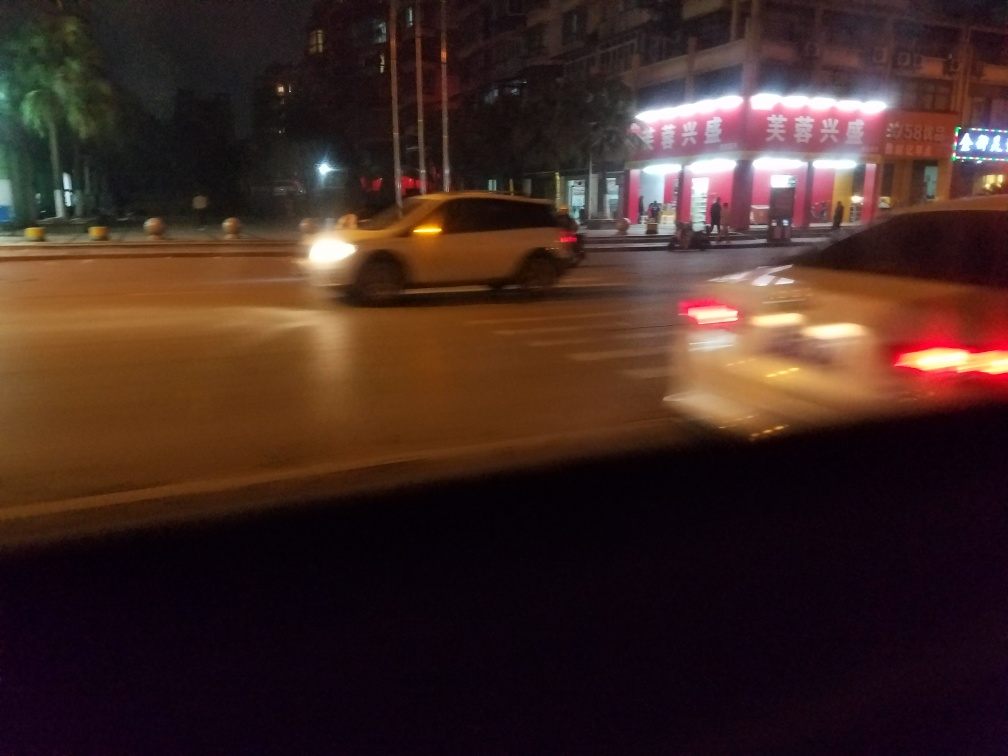What time of day does this image represent, and how can you tell? The image likely represents nighttime, as indicated by the darkness of the sky and the artificial lighting from street lamps and building signs. The lack of natural light and the presence of the vehicle headlights turned on also support this observation. 